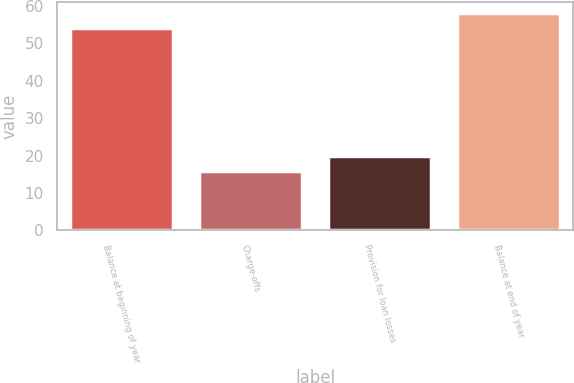Convert chart to OTSL. <chart><loc_0><loc_0><loc_500><loc_500><bar_chart><fcel>Balance at beginning of year<fcel>Charge-offs<fcel>Provision for loan losses<fcel>Balance at end of year<nl><fcel>54<fcel>16<fcel>20<fcel>58<nl></chart> 